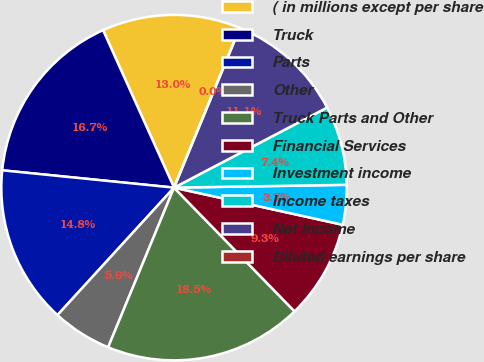Convert chart to OTSL. <chart><loc_0><loc_0><loc_500><loc_500><pie_chart><fcel>( in millions except per share<fcel>Truck<fcel>Parts<fcel>Other<fcel>Truck Parts and Other<fcel>Financial Services<fcel>Investment income<fcel>Income taxes<fcel>Net Income<fcel>Diluted earnings per share<nl><fcel>12.96%<fcel>16.66%<fcel>14.81%<fcel>5.56%<fcel>18.52%<fcel>9.26%<fcel>3.71%<fcel>7.41%<fcel>11.11%<fcel>0.0%<nl></chart> 